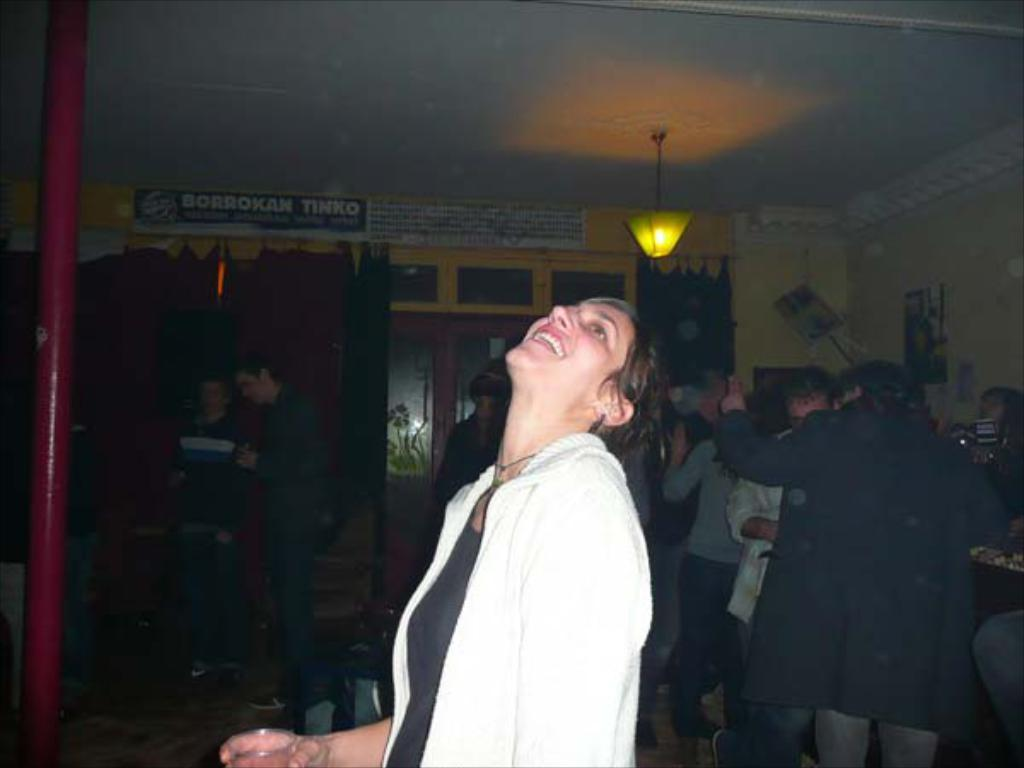What is the main subject of the image? There is a woman standing in the center of the image. What is the woman holding in the image? The woman is holding a glass. What can be seen in the background of the image? There is a group of people, curtains, windows, a wall, a pipeline, and a light in the background of the image. What type of glue is being used by the woman in the image? There is no glue present in the image; the woman is holding a glass. Can you see any rocks in the image? There are no rocks visible in the image. 